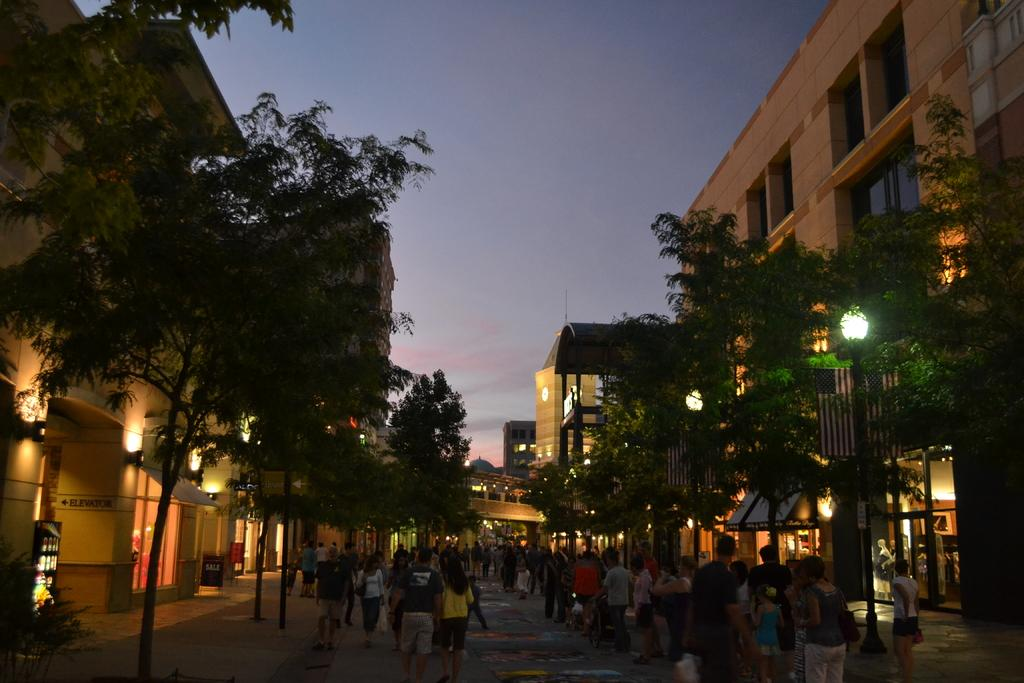What are the people in the center of the image doing? There are persons walking and standing in the center of the image. What can be seen in the background of the image? There are trees, buildings, lights, and poles in the background of the image. What type of food is being served in the ring in the image? There is no ring or food present in the image. Can you describe the mist surrounding the people in the image? There is no mist present in the image; it is a clear scene with people walking and standing in the center. 